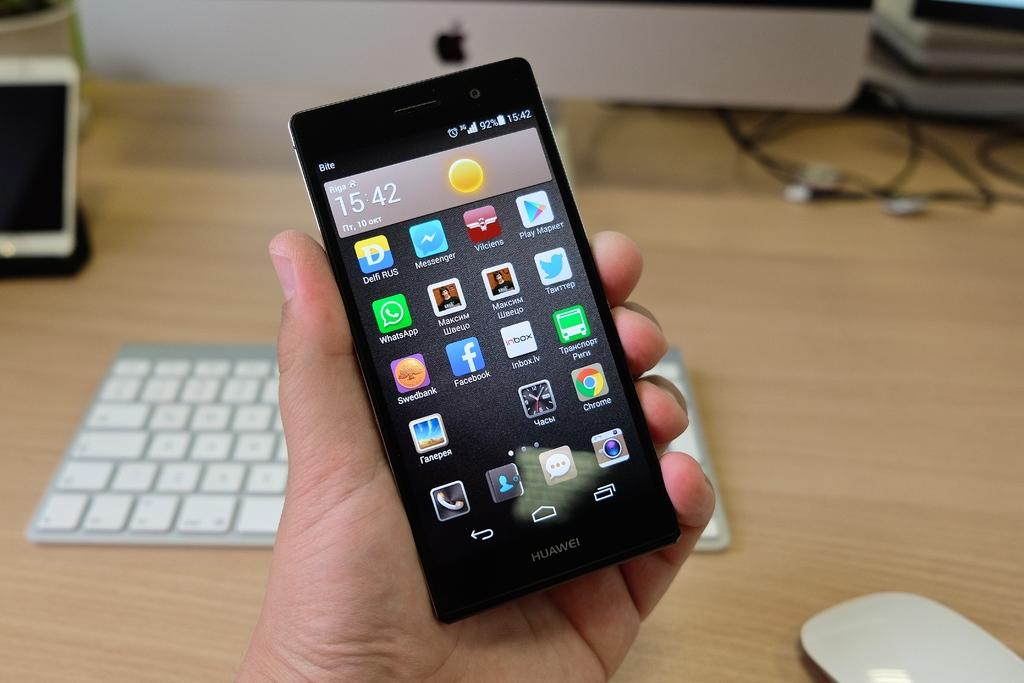<image>
Present a compact description of the photo's key features. A Huawei phone screen says the time is 15:42. 